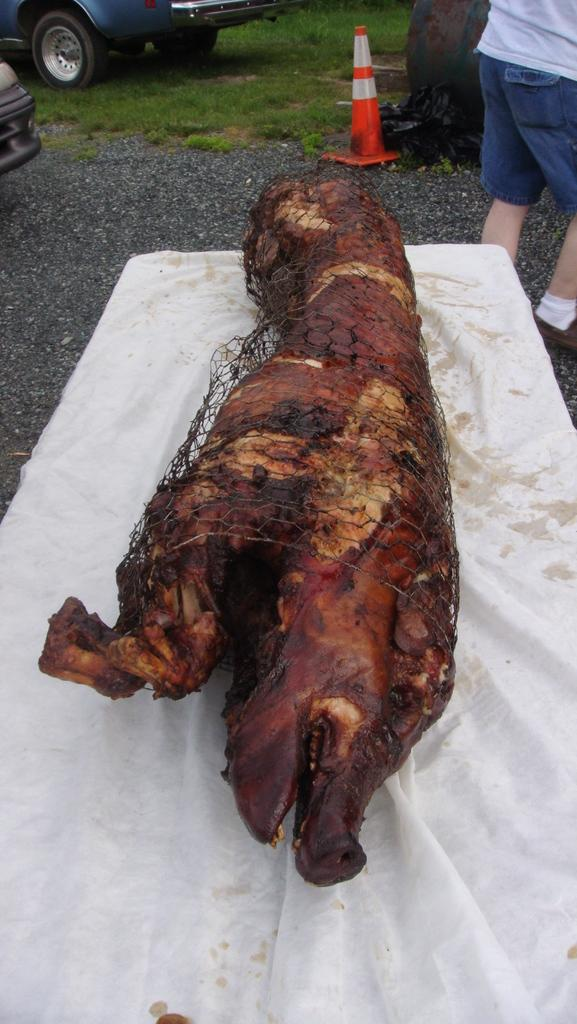What is the main subject of the image? There is a dead animal on the road in the image. Can you describe the man in the image? There is a man standing on the right side of the image. What can be seen in the background of the image? There is a vehicle on the grassland and a tree in the background of the image. What is placed on the vehicle in the background? There is a traffic cone on the vehicle in the background of the image. What part of the man's body is helping to lift the dead animal in the image? There is no indication in the image that the man is lifting the dead animal, nor is there any information about which part of his body might be involved in such an action. 